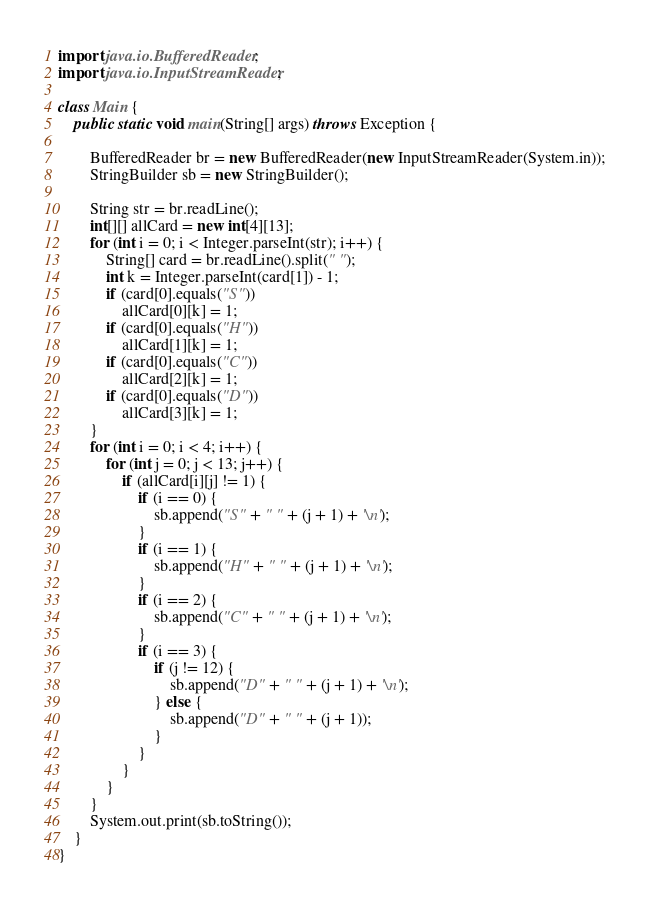<code> <loc_0><loc_0><loc_500><loc_500><_Java_>import java.io.BufferedReader;
import java.io.InputStreamReader;

class Main {
	public static void main(String[] args) throws Exception {

		BufferedReader br = new BufferedReader(new InputStreamReader(System.in));
		StringBuilder sb = new StringBuilder();

		String str = br.readLine();
		int[][] allCard = new int[4][13];
		for (int i = 0; i < Integer.parseInt(str); i++) {
			String[] card = br.readLine().split(" ");
			int k = Integer.parseInt(card[1]) - 1;
			if (card[0].equals("S"))
				allCard[0][k] = 1;
			if (card[0].equals("H"))
				allCard[1][k] = 1;
			if (card[0].equals("C"))
				allCard[2][k] = 1;
			if (card[0].equals("D"))
				allCard[3][k] = 1;
		}
		for (int i = 0; i < 4; i++) {
			for (int j = 0; j < 13; j++) {
				if (allCard[i][j] != 1) {
					if (i == 0) {
						sb.append("S" + " " + (j + 1) + '\n');
					}
					if (i == 1) {
						sb.append("H" + " " + (j + 1) + '\n');
					}
					if (i == 2) {
						sb.append("C" + " " + (j + 1) + '\n');
					}
					if (i == 3) {
						if (j != 12) {
							sb.append("D" + " " + (j + 1) + '\n');
						} else {
							sb.append("D" + " " + (j + 1));
						}
					}
				}
			}
		}
		System.out.print(sb.toString());
	}
}</code> 